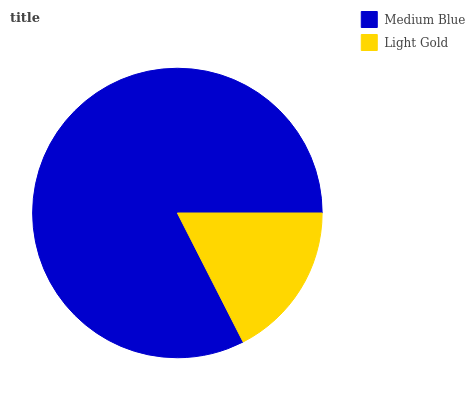Is Light Gold the minimum?
Answer yes or no. Yes. Is Medium Blue the maximum?
Answer yes or no. Yes. Is Light Gold the maximum?
Answer yes or no. No. Is Medium Blue greater than Light Gold?
Answer yes or no. Yes. Is Light Gold less than Medium Blue?
Answer yes or no. Yes. Is Light Gold greater than Medium Blue?
Answer yes or no. No. Is Medium Blue less than Light Gold?
Answer yes or no. No. Is Medium Blue the high median?
Answer yes or no. Yes. Is Light Gold the low median?
Answer yes or no. Yes. Is Light Gold the high median?
Answer yes or no. No. Is Medium Blue the low median?
Answer yes or no. No. 